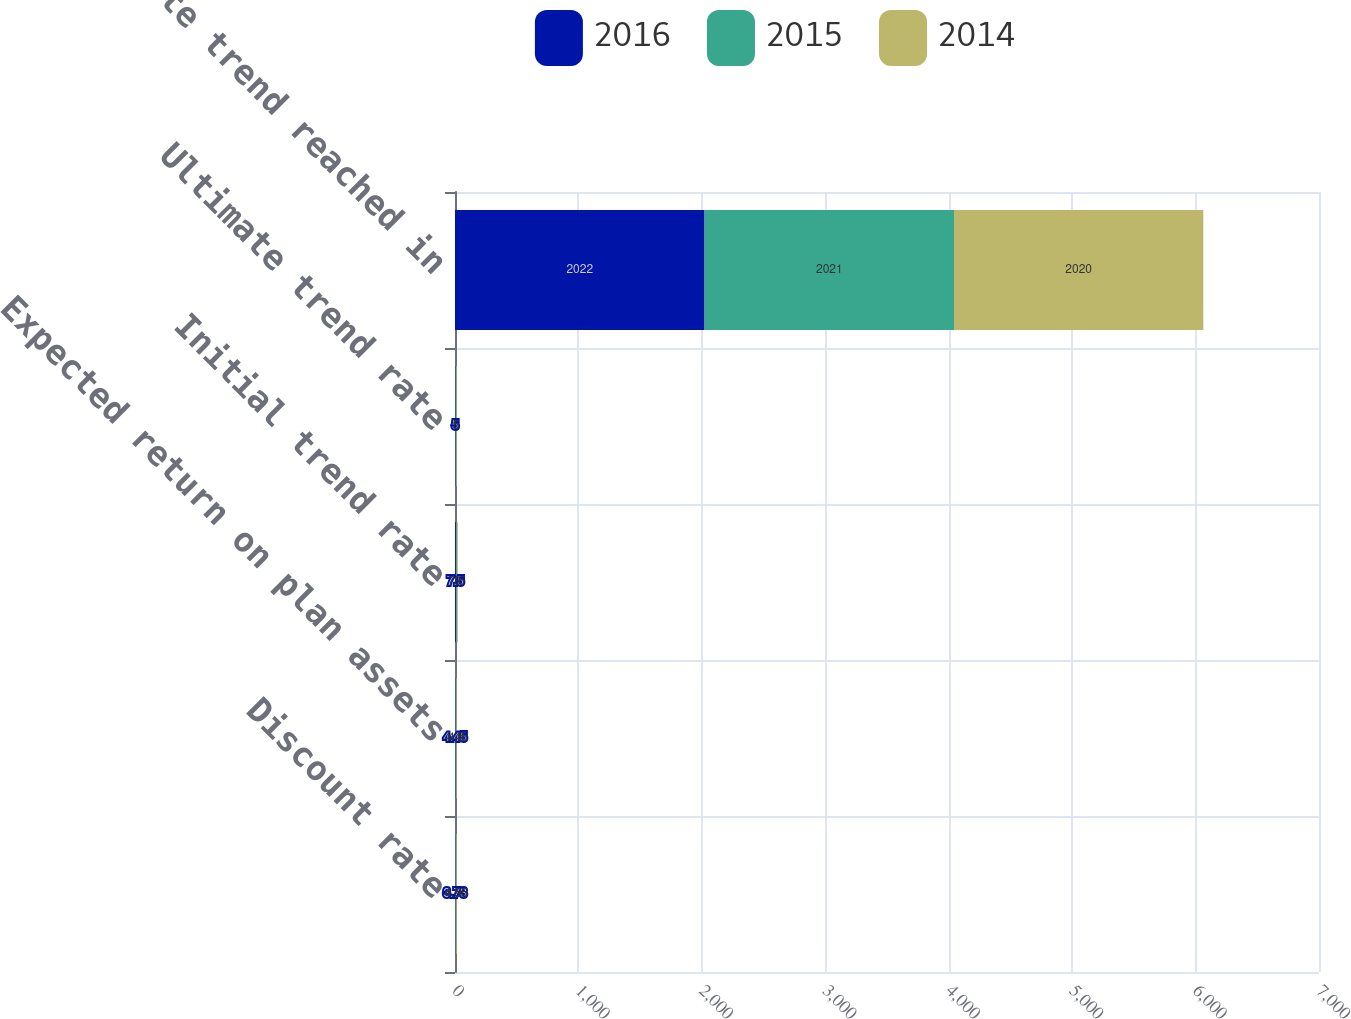Convert chart. <chart><loc_0><loc_0><loc_500><loc_500><stacked_bar_chart><ecel><fcel>Discount rate<fcel>Expected return on plan assets<fcel>Initial trend rate<fcel>Ultimate trend rate<fcel>Ultimate trend reached in<nl><fcel>2016<fcel>3.73<fcel>4.45<fcel>7.5<fcel>5<fcel>2022<nl><fcel>2015<fcel>4.55<fcel>4.45<fcel>7.5<fcel>5<fcel>2021<nl><fcel>2014<fcel>4.95<fcel>4.6<fcel>8<fcel>5<fcel>2020<nl></chart> 